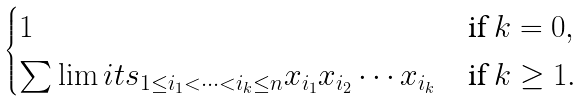Convert formula to latex. <formula><loc_0><loc_0><loc_500><loc_500>\begin{cases} 1 & \text {if} \ k = 0 , \\ \sum \lim i t s _ { 1 \leq i _ { 1 } < \cdots < i _ { k } \leq n } x _ { i _ { 1 } } x _ { i _ { 2 } } \cdots x _ { i _ { k } } & \text {if} \ k \geq 1 . \end{cases}</formula> 